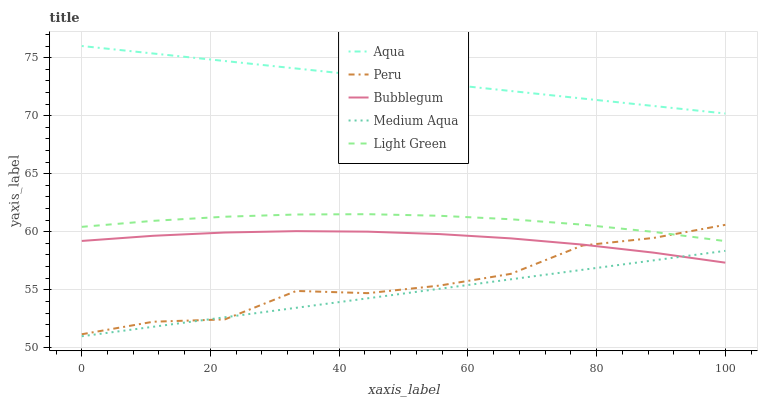Does Light Green have the minimum area under the curve?
Answer yes or no. No. Does Light Green have the maximum area under the curve?
Answer yes or no. No. Is Light Green the smoothest?
Answer yes or no. No. Is Light Green the roughest?
Answer yes or no. No. Does Light Green have the lowest value?
Answer yes or no. No. Does Light Green have the highest value?
Answer yes or no. No. Is Medium Aqua less than Aqua?
Answer yes or no. Yes. Is Light Green greater than Bubblegum?
Answer yes or no. Yes. Does Medium Aqua intersect Aqua?
Answer yes or no. No. 